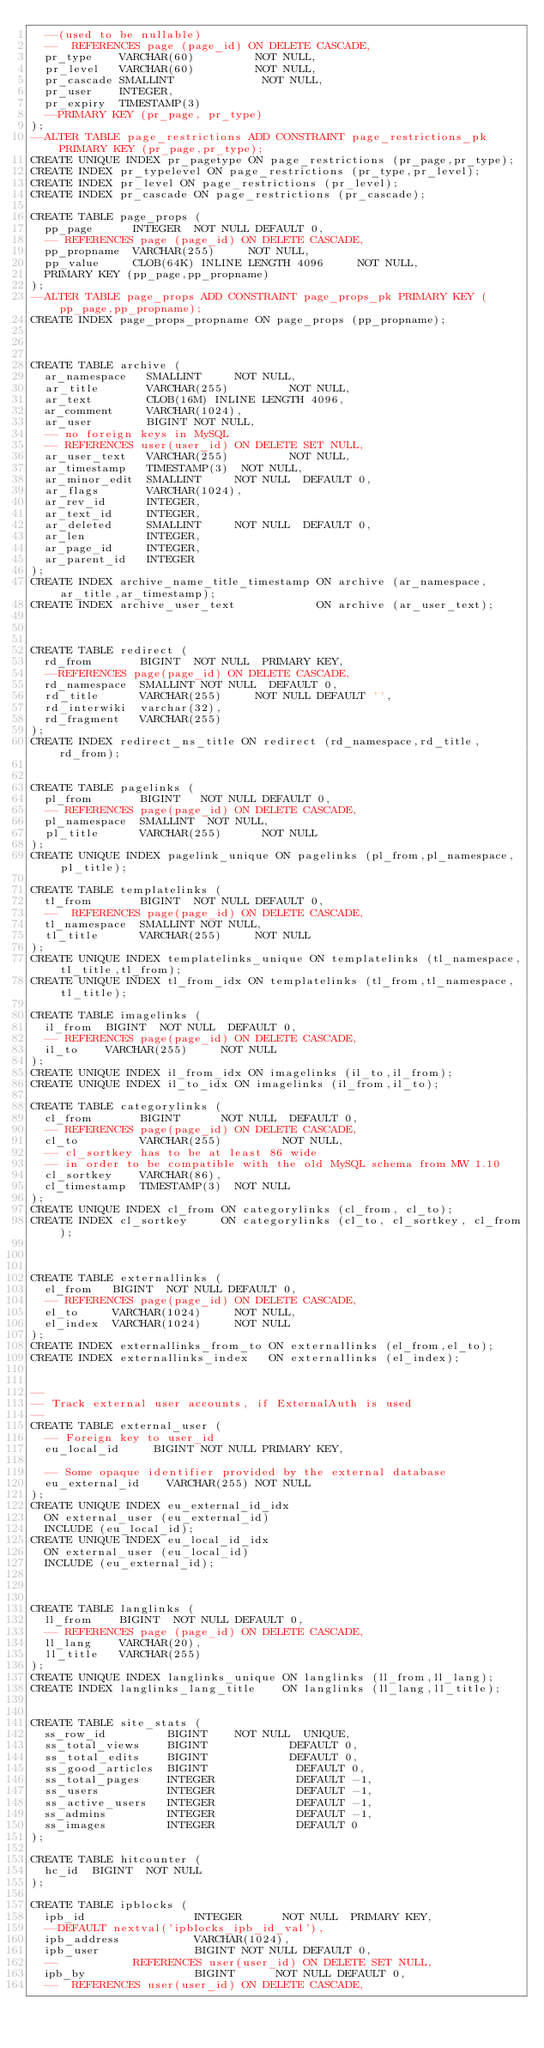Convert code to text. <code><loc_0><loc_0><loc_500><loc_500><_SQL_>  --(used to be nullable)
  --  REFERENCES page (page_id) ON DELETE CASCADE,
  pr_type    VARCHAR(60)         NOT NULL,
  pr_level   VARCHAR(60)         NOT NULL,
  pr_cascade SMALLINT             NOT NULL,
  pr_user    INTEGER,
  pr_expiry  TIMESTAMP(3)
  --PRIMARY KEY (pr_page, pr_type)
);
--ALTER TABLE page_restrictions ADD CONSTRAINT page_restrictions_pk PRIMARY KEY (pr_page,pr_type);
CREATE UNIQUE INDEX pr_pagetype ON page_restrictions (pr_page,pr_type);
CREATE INDEX pr_typelevel ON page_restrictions (pr_type,pr_level);
CREATE INDEX pr_level ON page_restrictions (pr_level);
CREATE INDEX pr_cascade ON page_restrictions (pr_cascade);

CREATE TABLE page_props (
  pp_page      INTEGER  NOT NULL DEFAULT 0,
  -- REFERENCES page (page_id) ON DELETE CASCADE,
  pp_propname  VARCHAR(255)     NOT NULL,
  pp_value     CLOB(64K) INLINE LENGTH 4096     NOT NULL,
  PRIMARY KEY (pp_page,pp_propname) 
);
--ALTER TABLE page_props ADD CONSTRAINT page_props_pk PRIMARY KEY (pp_page,pp_propname);
CREATE INDEX page_props_propname ON page_props (pp_propname);



CREATE TABLE archive (
  ar_namespace   SMALLINT     NOT NULL,
  ar_title       VARCHAR(255)         NOT NULL,
  ar_text        CLOB(16M) INLINE LENGTH 4096,
  ar_comment     VARCHAR(1024),
  ar_user        BIGINT NOT NULL,
  -- no foreign keys in MySQL
  -- REFERENCES user(user_id) ON DELETE SET NULL,
  ar_user_text   VARCHAR(255)         NOT NULL,
  ar_timestamp   TIMESTAMP(3)  NOT NULL,
  ar_minor_edit  SMALLINT     NOT NULL  DEFAULT 0,
  ar_flags       VARCHAR(1024),
  ar_rev_id      INTEGER,
  ar_text_id     INTEGER,
  ar_deleted     SMALLINT     NOT NULL  DEFAULT 0,
  ar_len         INTEGER,
  ar_page_id     INTEGER,
  ar_parent_id   INTEGER
);
CREATE INDEX archive_name_title_timestamp ON archive (ar_namespace,ar_title,ar_timestamp);
CREATE INDEX archive_user_text            ON archive (ar_user_text);



CREATE TABLE redirect (
  rd_from       BIGINT  NOT NULL  PRIMARY KEY,
  --REFERENCES page(page_id) ON DELETE CASCADE,
  rd_namespace  SMALLINT NOT NULL  DEFAULT 0,
  rd_title      VARCHAR(255)     NOT NULL DEFAULT '',
  rd_interwiki  varchar(32),
  rd_fragment   VARCHAR(255)
);
CREATE INDEX redirect_ns_title ON redirect (rd_namespace,rd_title,rd_from);


CREATE TABLE pagelinks (
  pl_from       BIGINT   NOT NULL DEFAULT 0,
  -- REFERENCES page(page_id) ON DELETE CASCADE,
  pl_namespace  SMALLINT  NOT NULL,
  pl_title      VARCHAR(255)      NOT NULL
);
CREATE UNIQUE INDEX pagelink_unique ON pagelinks (pl_from,pl_namespace,pl_title);

CREATE TABLE templatelinks (
  tl_from       BIGINT  NOT NULL DEFAULT 0,
  --  REFERENCES page(page_id) ON DELETE CASCADE,
  tl_namespace  SMALLINT NOT NULL,
  tl_title      VARCHAR(255)     NOT NULL
);
CREATE UNIQUE INDEX templatelinks_unique ON templatelinks (tl_namespace,tl_title,tl_from);
CREATE UNIQUE INDEX tl_from_idx ON templatelinks (tl_from,tl_namespace,tl_title);

CREATE TABLE imagelinks (
  il_from  BIGINT  NOT NULL  DEFAULT 0,
  -- REFERENCES page(page_id) ON DELETE CASCADE,
  il_to    VARCHAR(255)     NOT NULL
);
CREATE UNIQUE INDEX il_from_idx ON imagelinks (il_to,il_from);
CREATE UNIQUE INDEX il_to_idx ON imagelinks (il_from,il_to);

CREATE TABLE categorylinks (
  cl_from       BIGINT      NOT NULL  DEFAULT 0,
  -- REFERENCES page(page_id) ON DELETE CASCADE,
  cl_to         VARCHAR(255)         NOT NULL,
  -- cl_sortkey has to be at least 86 wide 
  -- in order to be compatible with the old MySQL schema from MW 1.10
  cl_sortkey    VARCHAR(86),
  cl_timestamp  TIMESTAMP(3)  NOT NULL
);
CREATE UNIQUE INDEX cl_from ON categorylinks (cl_from, cl_to);
CREATE INDEX cl_sortkey     ON categorylinks (cl_to, cl_sortkey, cl_from);



CREATE TABLE externallinks (
  el_from   BIGINT  NOT NULL DEFAULT 0,
  -- REFERENCES page(page_id) ON DELETE CASCADE,
  el_to     VARCHAR(1024)     NOT NULL,
  el_index  VARCHAR(1024)     NOT NULL
);
CREATE INDEX externallinks_from_to ON externallinks (el_from,el_to);
CREATE INDEX externallinks_index   ON externallinks (el_index);


--
-- Track external user accounts, if ExternalAuth is used
--
CREATE TABLE external_user (
  -- Foreign key to user_id
  eu_local_id			BIGINT NOT NULL PRIMARY KEY,

  -- Some opaque identifier provided by the external database
  eu_external_id		VARCHAR(255) NOT NULL
);
CREATE UNIQUE INDEX eu_external_id_idx
	ON external_user (eu_external_id)
	INCLUDE (eu_local_id);
CREATE UNIQUE INDEX eu_local_id_idx
	ON external_user (eu_local_id)
	INCLUDE (eu_external_id);



CREATE TABLE langlinks (
  ll_from    BIGINT  NOT NULL DEFAULT 0,
  -- REFERENCES page (page_id) ON DELETE CASCADE,
  ll_lang    VARCHAR(20),
  ll_title   VARCHAR(255)
);
CREATE UNIQUE INDEX langlinks_unique ON langlinks (ll_from,ll_lang);
CREATE INDEX langlinks_lang_title    ON langlinks (ll_lang,ll_title);


CREATE TABLE site_stats (
  ss_row_id         BIGINT	  NOT NULL  UNIQUE,
  ss_total_views    BIGINT            DEFAULT 0,
  ss_total_edits    BIGINT            DEFAULT 0,
  ss_good_articles  BIGINT             DEFAULT 0,
  ss_total_pages    INTEGER            DEFAULT -1,
  ss_users          INTEGER            DEFAULT -1,
  ss_active_users   INTEGER            DEFAULT -1,
  ss_admins         INTEGER            DEFAULT -1,
  ss_images         INTEGER            DEFAULT 0
);

CREATE TABLE hitcounter (
  hc_id  BIGINT  NOT NULL
);

CREATE TABLE ipblocks (
  ipb_id                INTEGER      NOT NULL  PRIMARY KEY,
  --DEFAULT nextval('ipblocks_ipb_id_val'),
  ipb_address           VARCHAR(1024),
  ipb_user              BIGINT NOT NULL DEFAULT 0,
  --           REFERENCES user(user_id) ON DELETE SET NULL,
  ipb_by                BIGINT      NOT NULL DEFAULT 0,
  --  REFERENCES user(user_id) ON DELETE CASCADE,</code> 